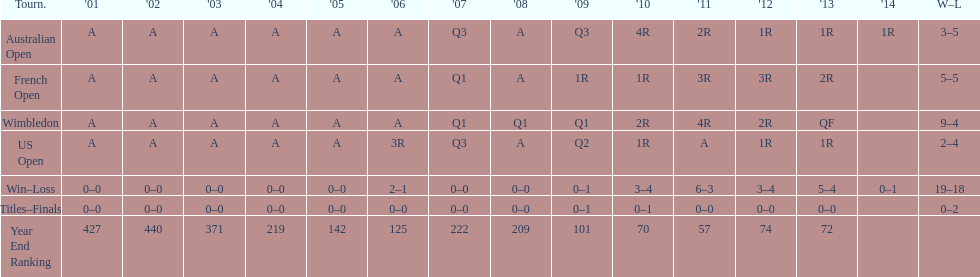What was this players average ranking between 2001 and 2006? 287. 